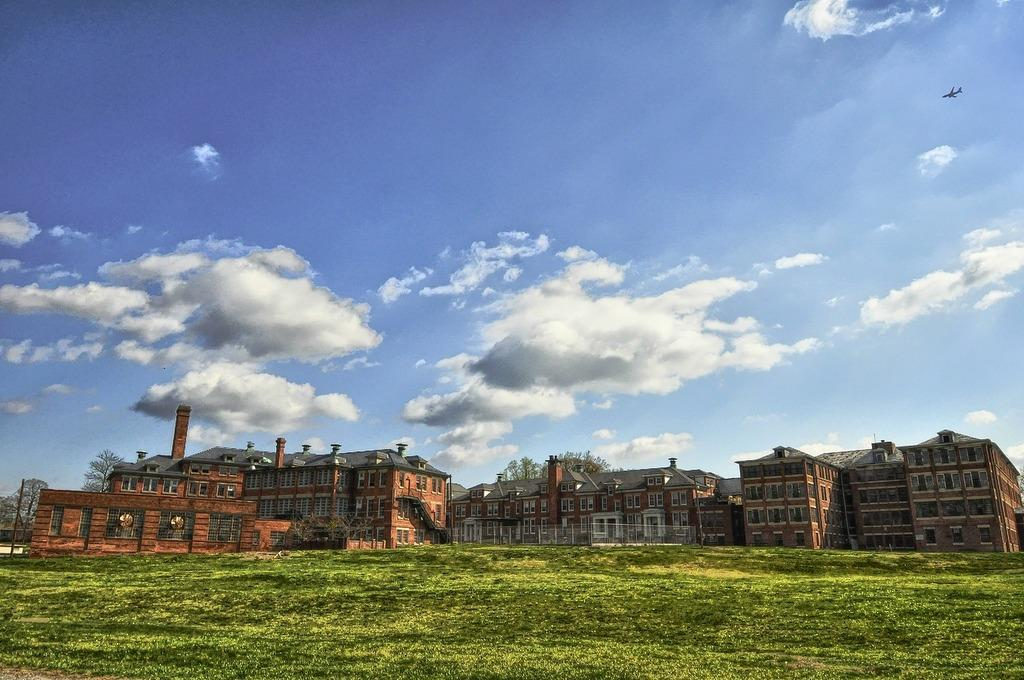What can be seen in the center of the image? There are buildings and trees in the center of the image. What is at the bottom of the image? There is grass at the bottom of the image. What is visible at the top of the image? The sky is visible at the top of the image. Can you describe any objects or vehicles in the sky? Yes, there is an aeroplane flying in the sky. What type of cabbage is growing in the cellar in the image? There is no cabbage or cellar present in the image. How many beans are visible on the trees in the image? There are no beans or trees with beans in the image. 